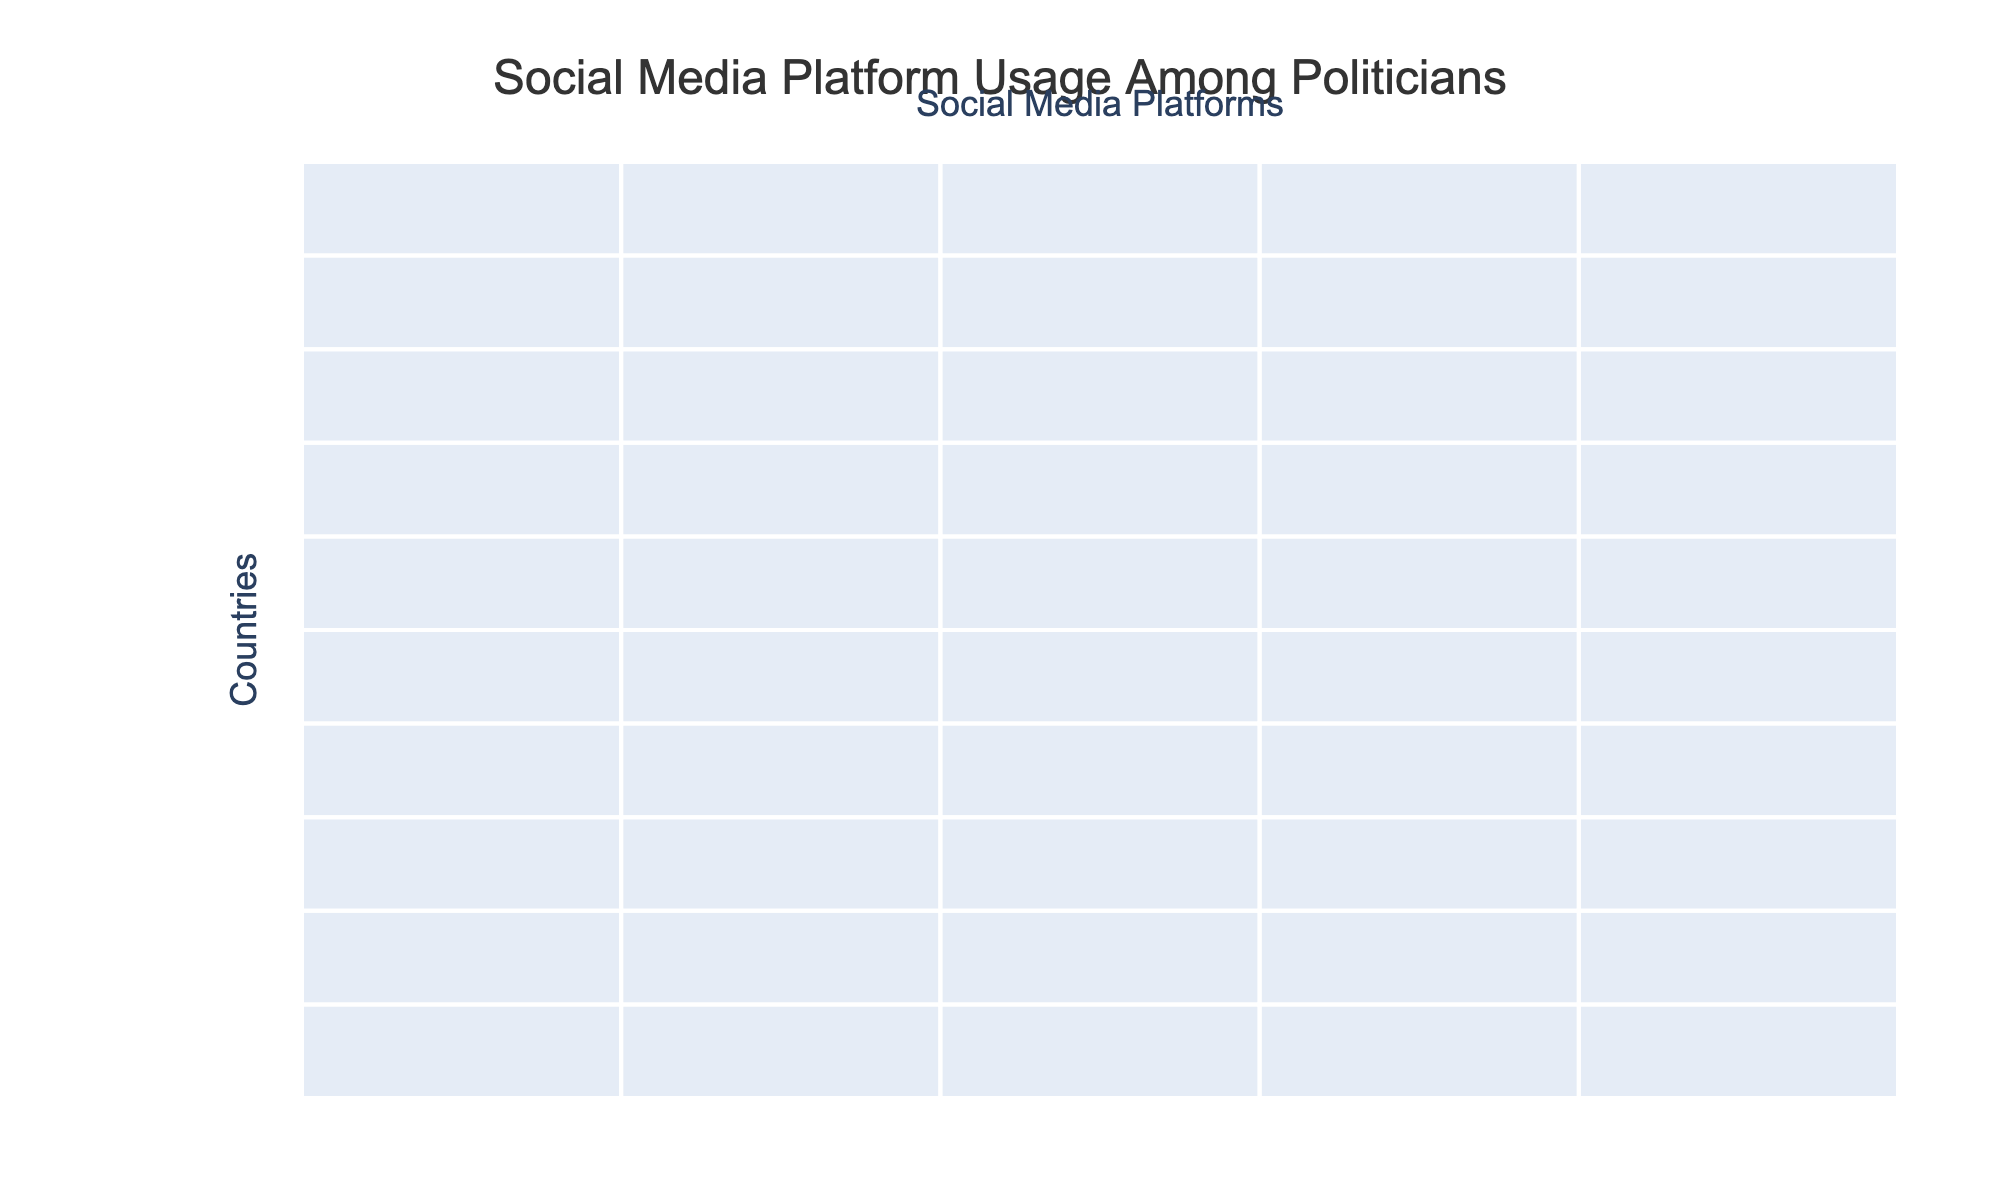What country has the highest usage percentage of Facebook among politicians? From the table, we can see the usage percentage for Facebook of each country listed. By comparing the values, we find that Brazil, with 95%, has the highest usage of Facebook among politicians.
Answer: Brazil Which country has the lowest TikTok usage by politicians? Looking at the TikTok usage percentages for all countries, Japan has the lowest percentage at 5%.
Answer: Japan What is the average percentage of Instagram usage among politicians in the listed countries? To find the average, sum the Instagram usage percentages (78 + 73 + 67 + 81 + 52 + 61 + 69 + 75 + 72 + 58) =  50 and then divide by 10 (the number of countries), giving (711 / 10 = 71.1).
Answer: 71.1% Is the usage of Twitter among politicians higher in the United States than in Canada? By checking the Twitter usage of both countries, the United States is at 92% while Canada is at 91%. Since 92% is greater than 91%, the answer is yes.
Answer: Yes What is the difference in Facebook usage between India and Germany? The Facebook usage in India is 93% and in Germany it is 79%. The difference can be calculated as 93% - 79% = 14%.
Answer: 14% Which social media platform has the lowest overall usage among the ten countries? By examining the percentages for each platform, we can see that TikTok has the lowest maximum usage at 25% (Brazil) and the lowest overall values in several countries. This indicates that TikTok is the least used platform among the ten countries listed.
Answer: TikTok What is the median percentage of YouTube usage among these countries? First, list the YouTube usage percentages in ascending order: 54%, 57%, 58%, 62%, 63%, 65%, 71%, 72%, 76%. With 10 values, the median is the average of the 5th and 6th values, (62 + 63) / 2 = 62.5%.
Answer: 62.5% Which country has the highest average social media platform usage among the options provided? To calculate the average usage for each country, sum the percentages for all platforms for each country and then divide by 5. Comparing these averages, Brazil has the highest average usage with a total of 89% across all platforms.
Answer: Brazil Is the usage of Facebook among politicians in South Korea above 75%? The Facebook usage in South Korea is 72%. Since 72% is less than 75%, the answer is no.
Answer: No Which country has a higher percentage of TikTok usage: South Korea or Japan? South Korea has a TikTok usage of 22% compared to Japan's 5%. Since 22% is greater than 5%, the answer is South Korea.
Answer: South Korea 